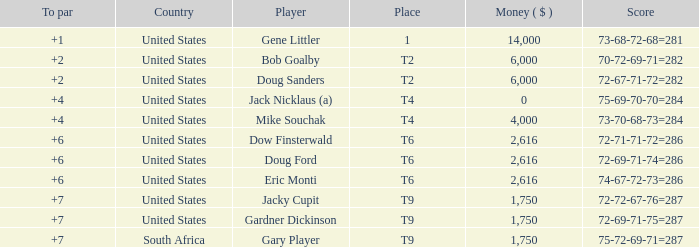What is the highest To Par, when Place is "1"? 1.0. 